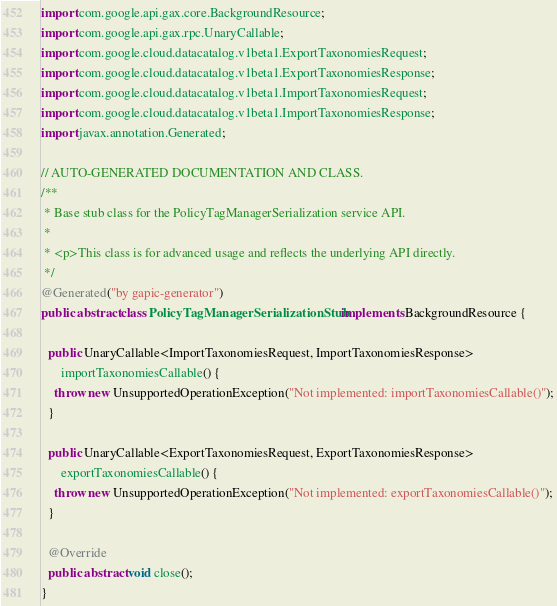<code> <loc_0><loc_0><loc_500><loc_500><_Java_>import com.google.api.gax.core.BackgroundResource;
import com.google.api.gax.rpc.UnaryCallable;
import com.google.cloud.datacatalog.v1beta1.ExportTaxonomiesRequest;
import com.google.cloud.datacatalog.v1beta1.ExportTaxonomiesResponse;
import com.google.cloud.datacatalog.v1beta1.ImportTaxonomiesRequest;
import com.google.cloud.datacatalog.v1beta1.ImportTaxonomiesResponse;
import javax.annotation.Generated;

// AUTO-GENERATED DOCUMENTATION AND CLASS.
/**
 * Base stub class for the PolicyTagManagerSerialization service API.
 *
 * <p>This class is for advanced usage and reflects the underlying API directly.
 */
@Generated("by gapic-generator")
public abstract class PolicyTagManagerSerializationStub implements BackgroundResource {

  public UnaryCallable<ImportTaxonomiesRequest, ImportTaxonomiesResponse>
      importTaxonomiesCallable() {
    throw new UnsupportedOperationException("Not implemented: importTaxonomiesCallable()");
  }

  public UnaryCallable<ExportTaxonomiesRequest, ExportTaxonomiesResponse>
      exportTaxonomiesCallable() {
    throw new UnsupportedOperationException("Not implemented: exportTaxonomiesCallable()");
  }

  @Override
  public abstract void close();
}
</code> 